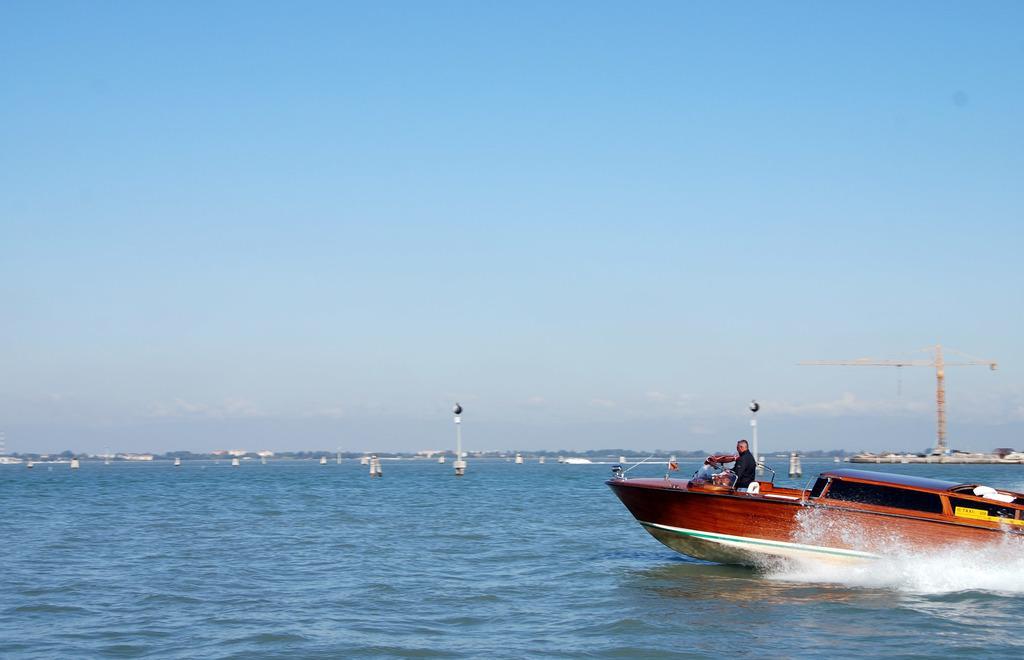Could you give a brief overview of what you see in this image? In this picture I can see boats on the water, there are poles, there is a crane, and in the background there is the sky. 